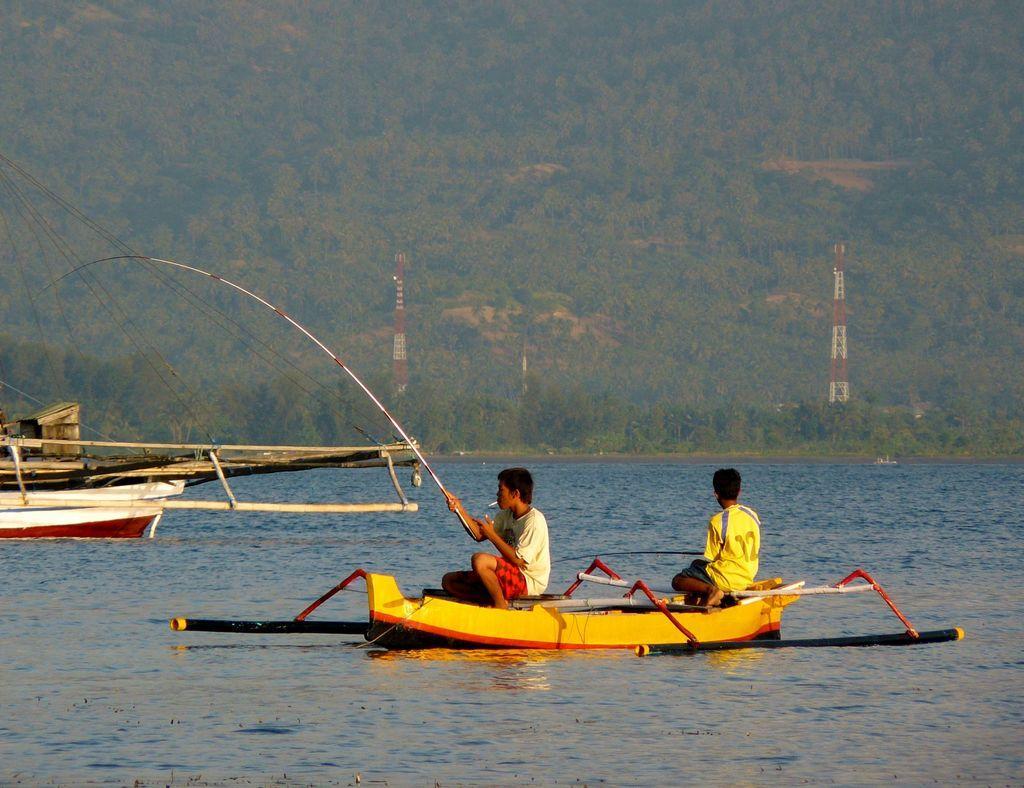How would you summarize this image in a sentence or two? In this picture I can see the water at the bottom, in the middle two boys are sitting in the boat and it looks like they are fishing. In the background I can see two towers and many trees. 